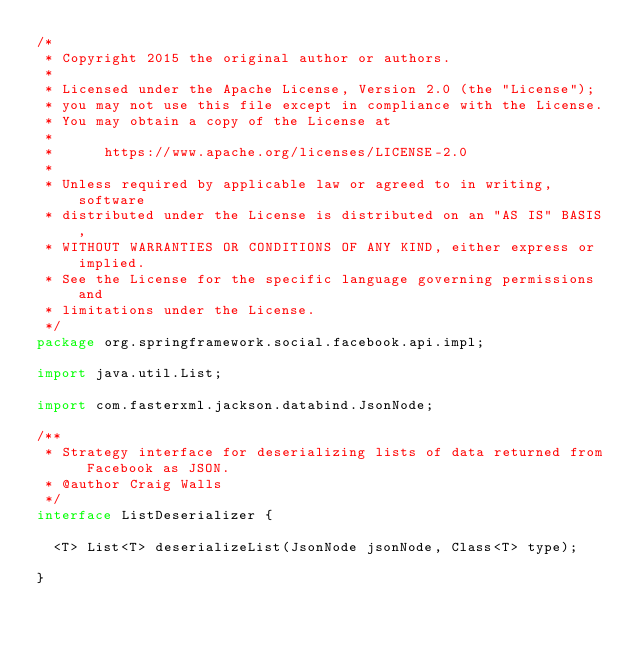<code> <loc_0><loc_0><loc_500><loc_500><_Java_>/*
 * Copyright 2015 the original author or authors.
 *
 * Licensed under the Apache License, Version 2.0 (the "License");
 * you may not use this file except in compliance with the License.
 * You may obtain a copy of the License at
 *
 *      https://www.apache.org/licenses/LICENSE-2.0
 *
 * Unless required by applicable law or agreed to in writing, software
 * distributed under the License is distributed on an "AS IS" BASIS,
 * WITHOUT WARRANTIES OR CONDITIONS OF ANY KIND, either express or implied.
 * See the License for the specific language governing permissions and
 * limitations under the License.
 */
package org.springframework.social.facebook.api.impl;

import java.util.List;

import com.fasterxml.jackson.databind.JsonNode;

/**
 * Strategy interface for deserializing lists of data returned from Facebook as JSON.
 * @author Craig Walls
 */
interface ListDeserializer {

	<T> List<T> deserializeList(JsonNode jsonNode, Class<T> type);

}
</code> 